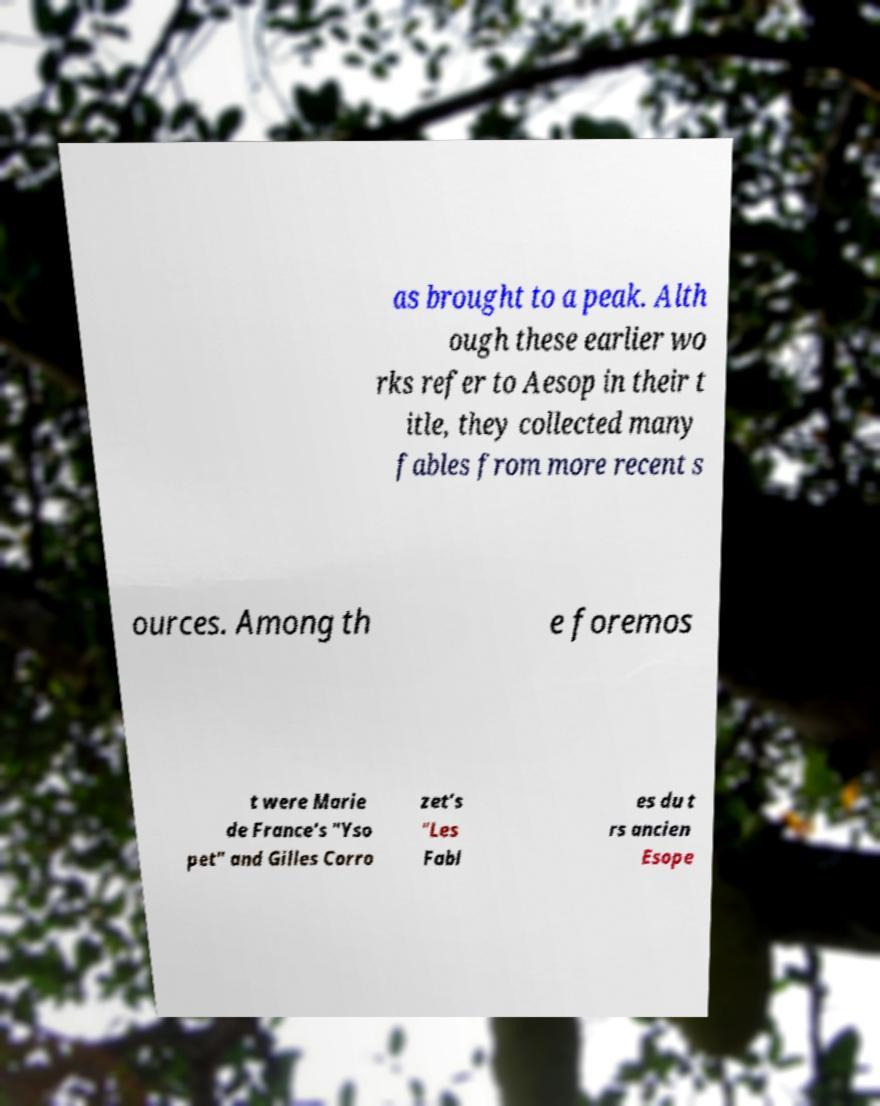What messages or text are displayed in this image? I need them in a readable, typed format. as brought to a peak. Alth ough these earlier wo rks refer to Aesop in their t itle, they collected many fables from more recent s ources. Among th e foremos t were Marie de France's "Yso pet" and Gilles Corro zet’s "Les Fabl es du t rs ancien Esope 